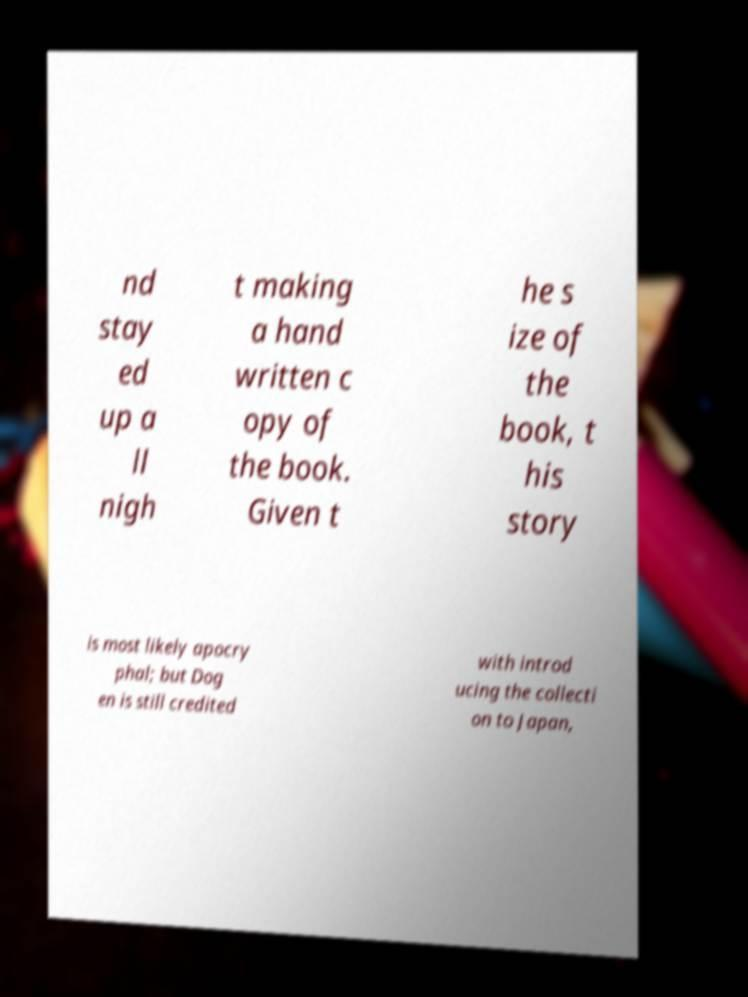Could you assist in decoding the text presented in this image and type it out clearly? nd stay ed up a ll nigh t making a hand written c opy of the book. Given t he s ize of the book, t his story is most likely apocry phal; but Dog en is still credited with introd ucing the collecti on to Japan, 